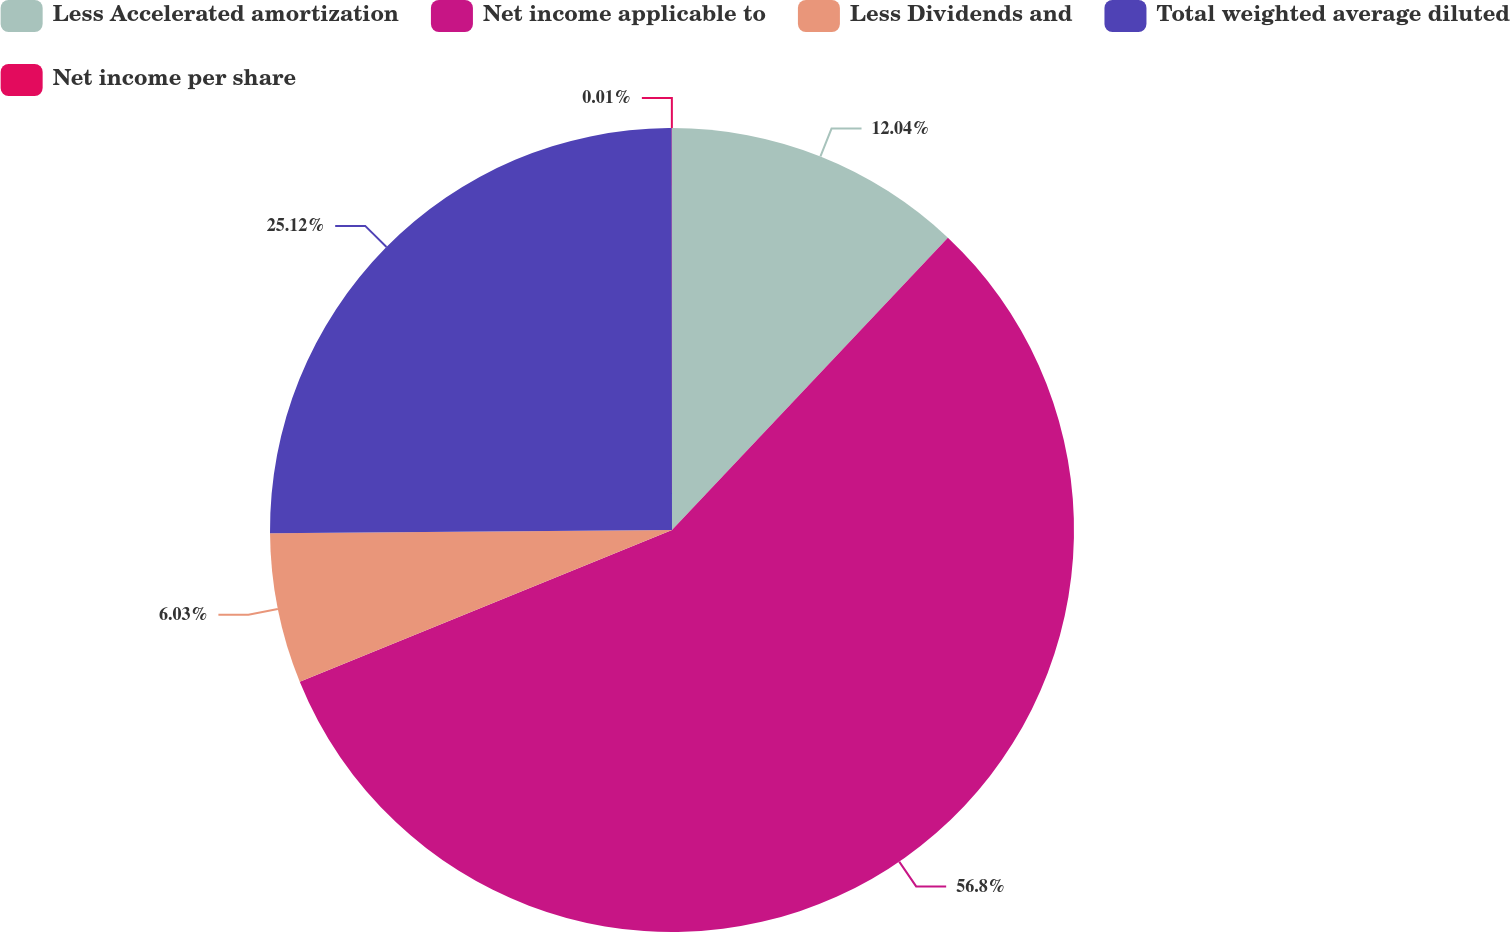Convert chart. <chart><loc_0><loc_0><loc_500><loc_500><pie_chart><fcel>Less Accelerated amortization<fcel>Net income applicable to<fcel>Less Dividends and<fcel>Total weighted average diluted<fcel>Net income per share<nl><fcel>12.04%<fcel>56.8%<fcel>6.03%<fcel>25.12%<fcel>0.01%<nl></chart> 